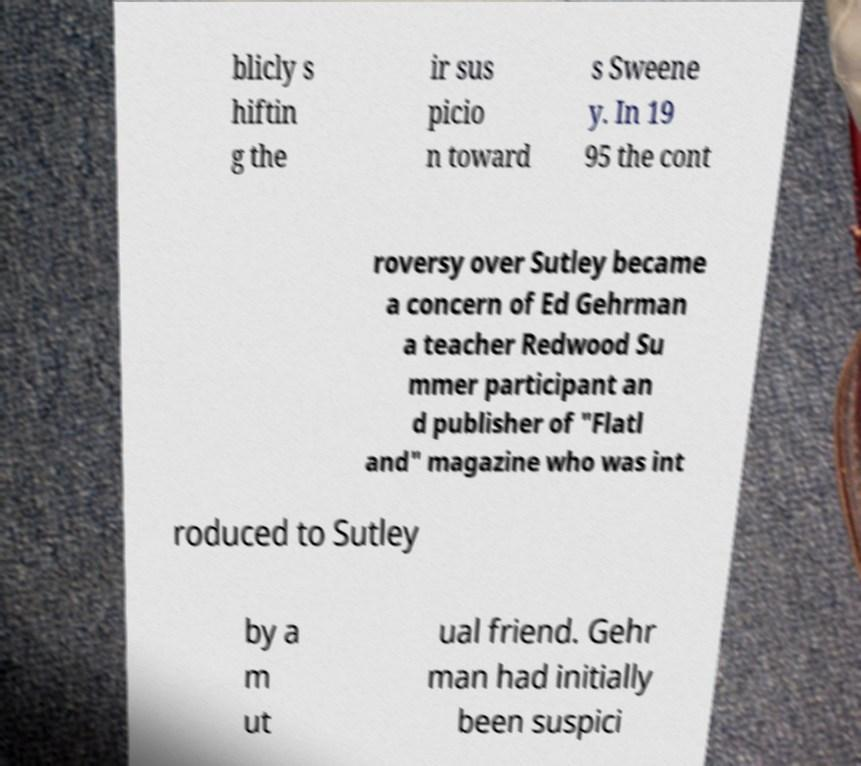There's text embedded in this image that I need extracted. Can you transcribe it verbatim? blicly s hiftin g the ir sus picio n toward s Sweene y. In 19 95 the cont roversy over Sutley became a concern of Ed Gehrman a teacher Redwood Su mmer participant an d publisher of "Flatl and" magazine who was int roduced to Sutley by a m ut ual friend. Gehr man had initially been suspici 